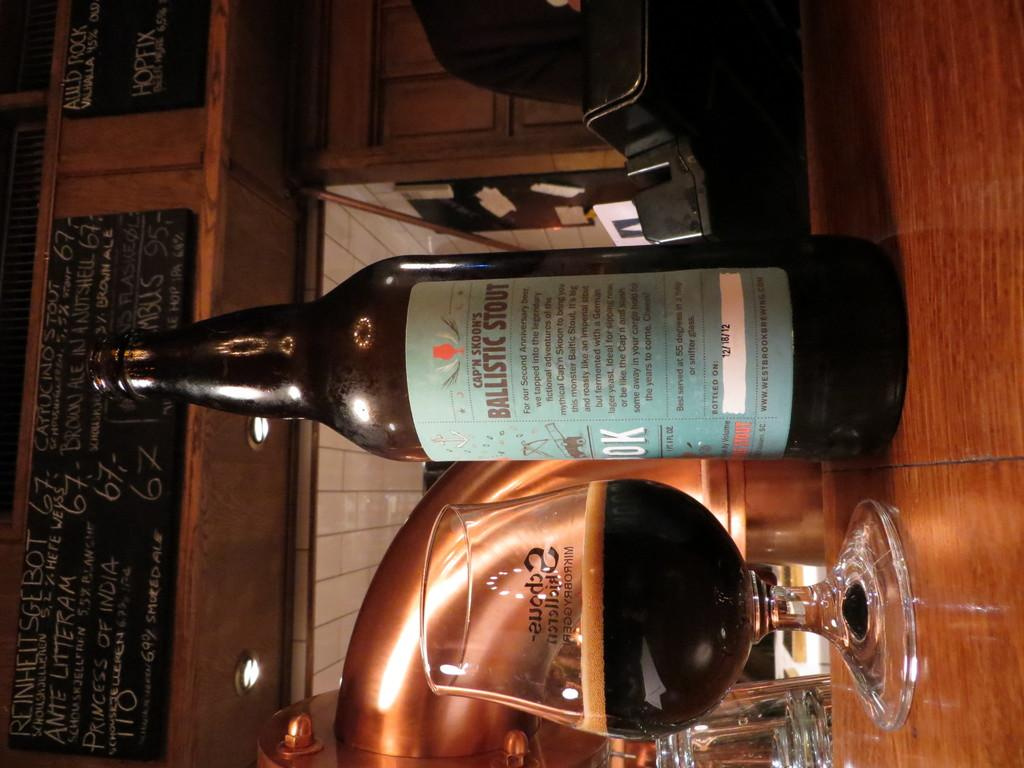Provide a one-sentence caption for the provided image. The bottle of beer on the table is Ballistic Stout. 